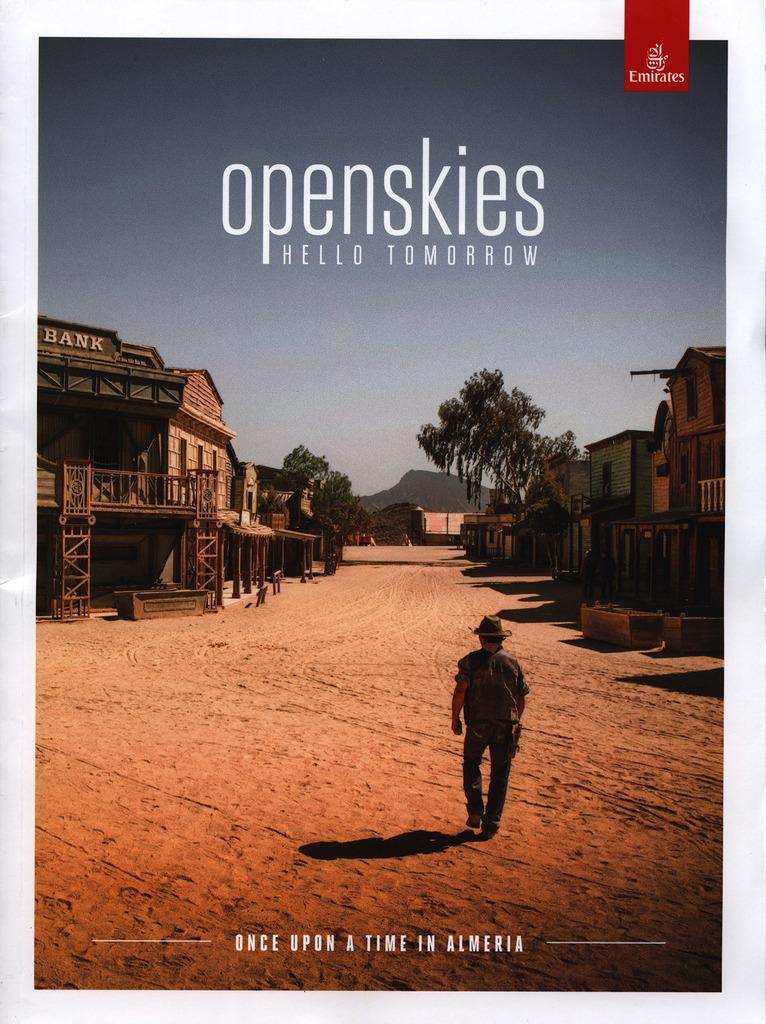Who or what is present in the image? There is a person in the image. What is the person wearing? The person is wearing a hat. What type of surface is the person standing on? The person is standing on sand. What structures can be seen in the background? There are buildings visible in the image. What type of vegetation is present in the image? There are trees visible in the image. What is written above and below the person? There is text written above and below the person. How many lizards are crawling on the person's hat in the image? There are no lizards present in the image. 